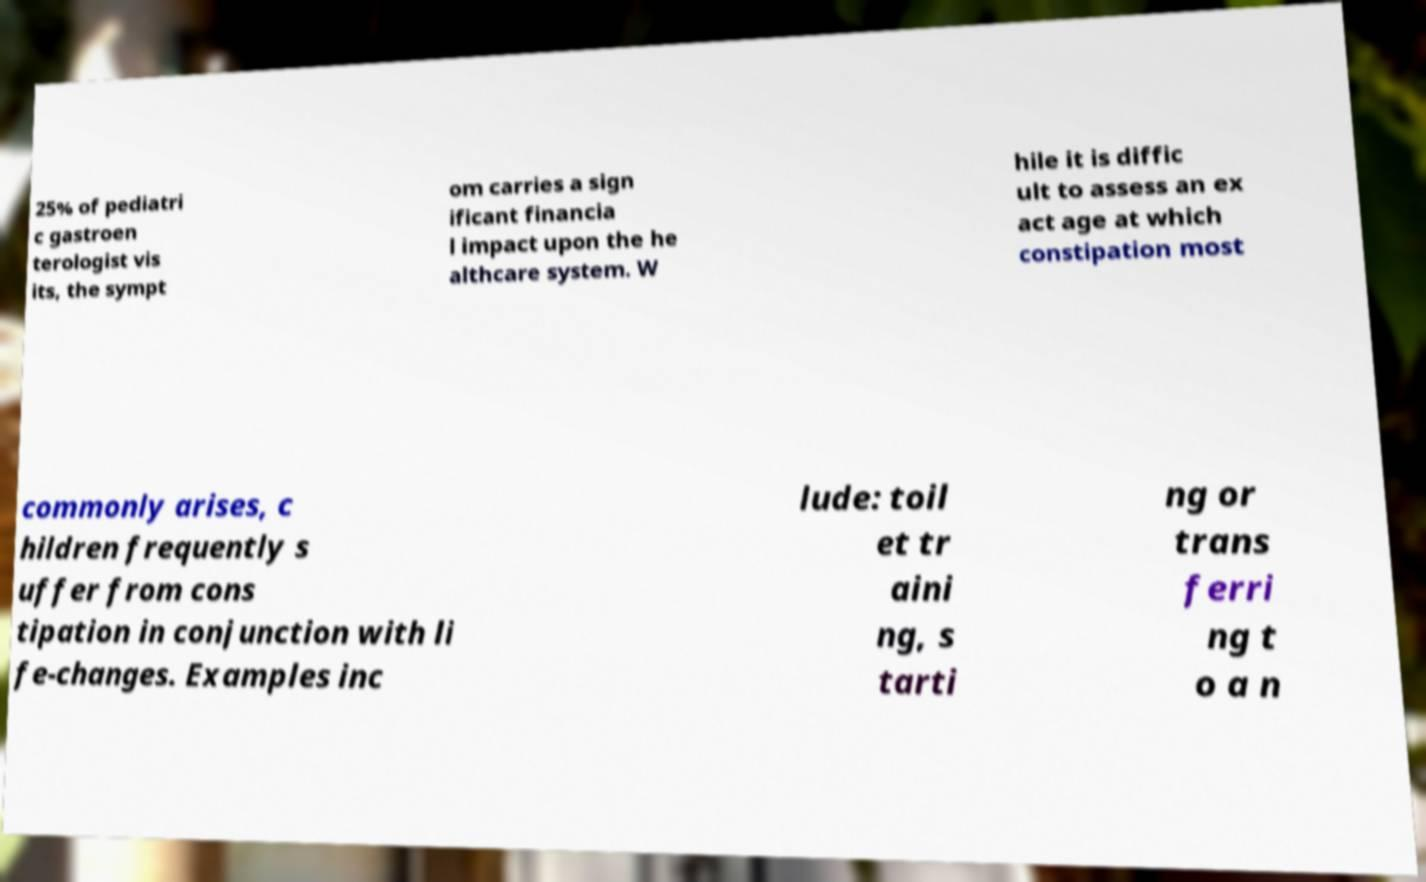Can you accurately transcribe the text from the provided image for me? 25% of pediatri c gastroen terologist vis its, the sympt om carries a sign ificant financia l impact upon the he althcare system. W hile it is diffic ult to assess an ex act age at which constipation most commonly arises, c hildren frequently s uffer from cons tipation in conjunction with li fe-changes. Examples inc lude: toil et tr aini ng, s tarti ng or trans ferri ng t o a n 